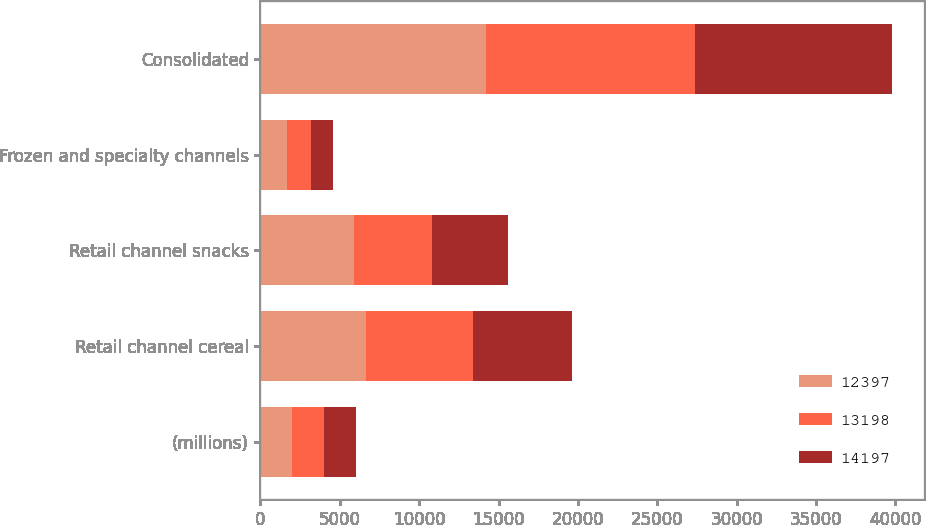Convert chart to OTSL. <chart><loc_0><loc_0><loc_500><loc_500><stacked_bar_chart><ecel><fcel>(millions)<fcel>Retail channel cereal<fcel>Retail channel snacks<fcel>Frozen and specialty channels<fcel>Consolidated<nl><fcel>12397<fcel>2012<fcel>6652<fcel>5891<fcel>1654<fcel>14197<nl><fcel>13198<fcel>2011<fcel>6730<fcel>4949<fcel>1519<fcel>13198<nl><fcel>14197<fcel>2010<fcel>6256<fcel>4734<fcel>1407<fcel>12397<nl></chart> 